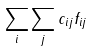<formula> <loc_0><loc_0><loc_500><loc_500>\sum _ { i } \sum _ { j } c _ { i j } f _ { i j }</formula> 